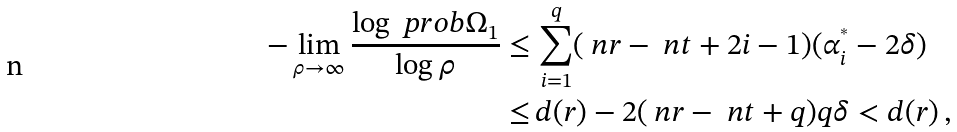<formula> <loc_0><loc_0><loc_500><loc_500>- \lim _ { \rho \rightarrow \infty } \frac { \log \ p r o b { \Omega _ { 1 } } } { \log \rho } \leq & \, \sum _ { i = 1 } ^ { q } ( \ n r - \ n t + 2 i - 1 ) ( \alpha _ { i } ^ { ^ { * } } - 2 \delta ) \\ \leq & \, d ( r ) - 2 ( \ n r - \ n t + q ) q \delta < d ( r ) \, ,</formula> 